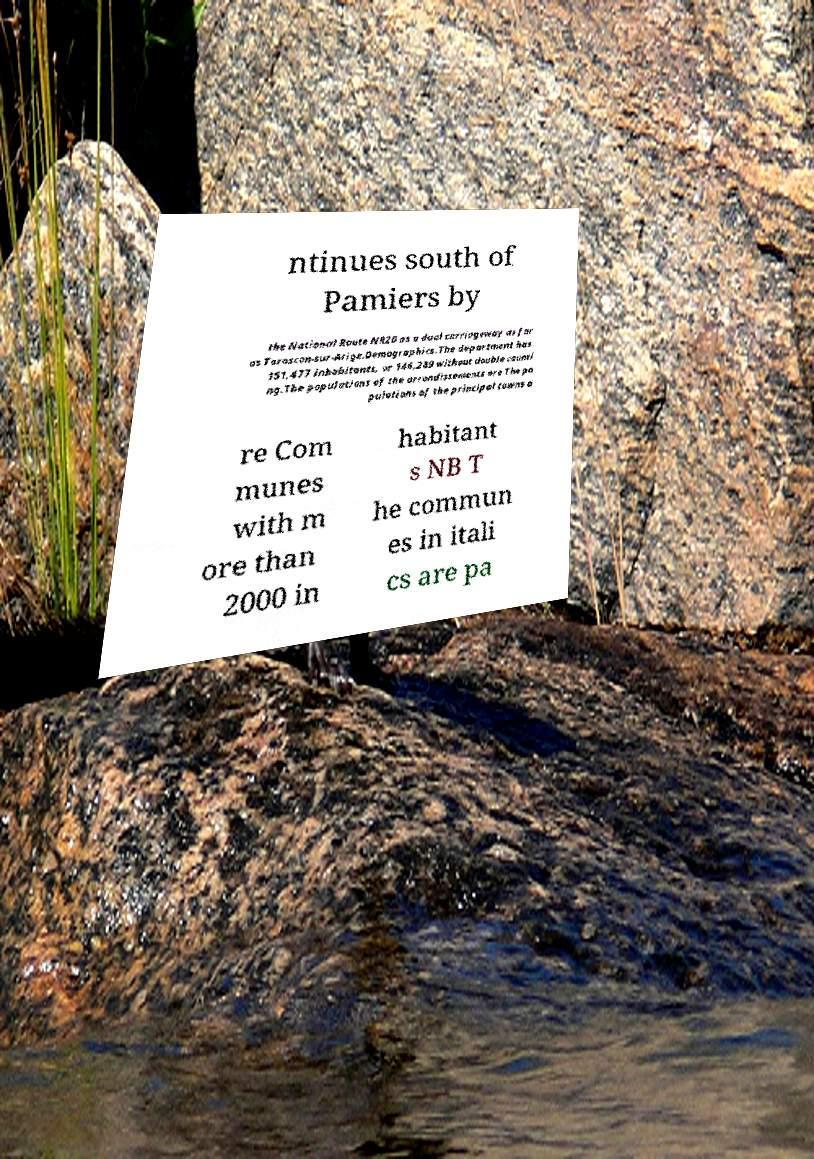Can you accurately transcribe the text from the provided image for me? ntinues south of Pamiers by the National Route NR20 as a dual carriageway as far as Tarascon-sur-Arige.Demographics.The department has 151,477 inhabitants, or 146,289 without double counti ng.The populations of the arrondissements are The po pulations of the principal towns a re Com munes with m ore than 2000 in habitant s NB T he commun es in itali cs are pa 